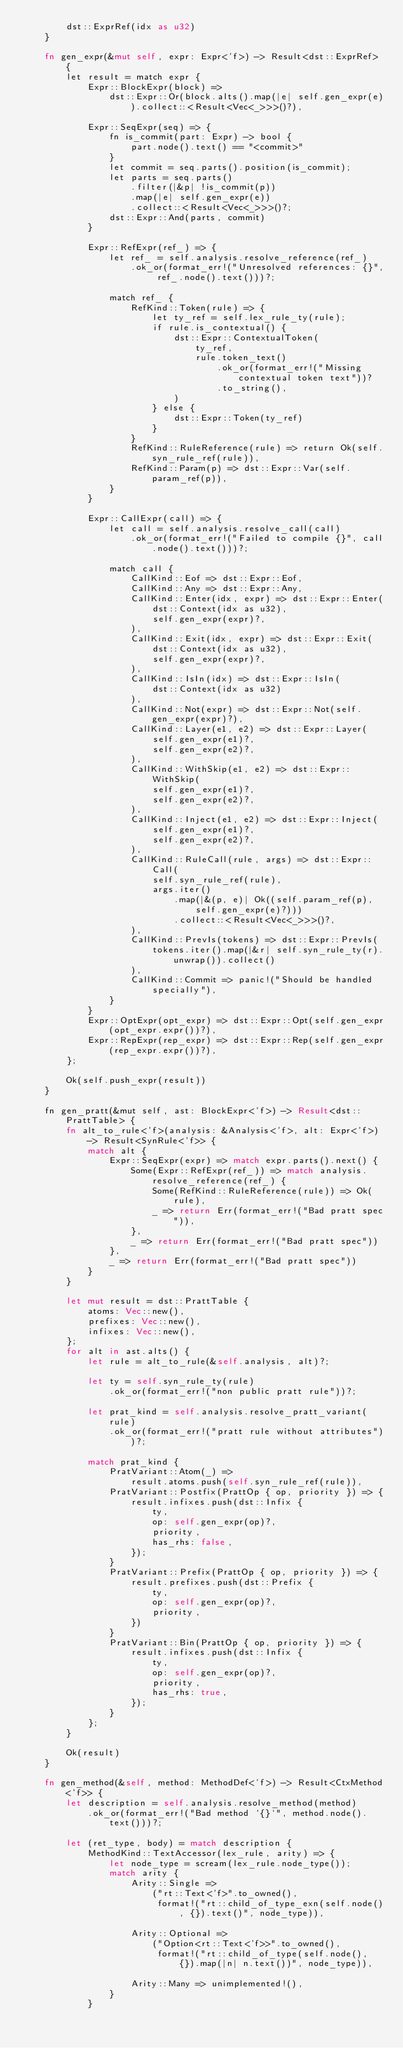<code> <loc_0><loc_0><loc_500><loc_500><_Rust_>        dst::ExprRef(idx as u32)
    }

    fn gen_expr(&mut self, expr: Expr<'f>) -> Result<dst::ExprRef> {
        let result = match expr {
            Expr::BlockExpr(block) =>
                dst::Expr::Or(block.alts().map(|e| self.gen_expr(e)).collect::<Result<Vec<_>>>()?),

            Expr::SeqExpr(seq) => {
                fn is_commit(part: Expr) -> bool {
                    part.node().text() == "<commit>"
                }
                let commit = seq.parts().position(is_commit);
                let parts = seq.parts()
                    .filter(|&p| !is_commit(p))
                    .map(|e| self.gen_expr(e))
                    .collect::<Result<Vec<_>>>()?;
                dst::Expr::And(parts, commit)
            }

            Expr::RefExpr(ref_) => {
                let ref_ = self.analysis.resolve_reference(ref_)
                    .ok_or(format_err!("Unresolved references: {}", ref_.node().text()))?;

                match ref_ {
                    RefKind::Token(rule) => {
                        let ty_ref = self.lex_rule_ty(rule);
                        if rule.is_contextual() {
                            dst::Expr::ContextualToken(
                                ty_ref,
                                rule.token_text()
                                    .ok_or(format_err!("Missing contextual token text"))?
                                    .to_string(),
                            )
                        } else {
                            dst::Expr::Token(ty_ref)
                        }
                    }
                    RefKind::RuleReference(rule) => return Ok(self.syn_rule_ref(rule)),
                    RefKind::Param(p) => dst::Expr::Var(self.param_ref(p)),
                }
            }

            Expr::CallExpr(call) => {
                let call = self.analysis.resolve_call(call)
                    .ok_or(format_err!("Failed to compile {}", call.node().text()))?;

                match call {
                    CallKind::Eof => dst::Expr::Eof,
                    CallKind::Any => dst::Expr::Any,
                    CallKind::Enter(idx, expr) => dst::Expr::Enter(
                        dst::Context(idx as u32),
                        self.gen_expr(expr)?,
                    ),
                    CallKind::Exit(idx, expr) => dst::Expr::Exit(
                        dst::Context(idx as u32),
                        self.gen_expr(expr)?,
                    ),
                    CallKind::IsIn(idx) => dst::Expr::IsIn(
                        dst::Context(idx as u32)
                    ),
                    CallKind::Not(expr) => dst::Expr::Not(self.gen_expr(expr)?),
                    CallKind::Layer(e1, e2) => dst::Expr::Layer(
                        self.gen_expr(e1)?,
                        self.gen_expr(e2)?,
                    ),
                    CallKind::WithSkip(e1, e2) => dst::Expr::WithSkip(
                        self.gen_expr(e1)?,
                        self.gen_expr(e2)?,
                    ),
                    CallKind::Inject(e1, e2) => dst::Expr::Inject(
                        self.gen_expr(e1)?,
                        self.gen_expr(e2)?,
                    ),
                    CallKind::RuleCall(rule, args) => dst::Expr::Call(
                        self.syn_rule_ref(rule),
                        args.iter()
                            .map(|&(p, e)| Ok((self.param_ref(p), self.gen_expr(e)?)))
                            .collect::<Result<Vec<_>>>()?,
                    ),
                    CallKind::PrevIs(tokens) => dst::Expr::PrevIs(
                        tokens.iter().map(|&r| self.syn_rule_ty(r).unwrap()).collect()
                    ),
                    CallKind::Commit => panic!("Should be handled specially"),
                }
            }
            Expr::OptExpr(opt_expr) => dst::Expr::Opt(self.gen_expr(opt_expr.expr())?),
            Expr::RepExpr(rep_expr) => dst::Expr::Rep(self.gen_expr(rep_expr.expr())?),
        };

        Ok(self.push_expr(result))
    }

    fn gen_pratt(&mut self, ast: BlockExpr<'f>) -> Result<dst::PrattTable> {
        fn alt_to_rule<'f>(analysis: &Analysis<'f>, alt: Expr<'f>) -> Result<SynRule<'f>> {
            match alt {
                Expr::SeqExpr(expr) => match expr.parts().next() {
                    Some(Expr::RefExpr(ref_)) => match analysis.resolve_reference(ref_) {
                        Some(RefKind::RuleReference(rule)) => Ok(rule),
                        _ => return Err(format_err!("Bad pratt spec")),
                    },
                    _ => return Err(format_err!("Bad pratt spec"))
                },
                _ => return Err(format_err!("Bad pratt spec"))
            }
        }

        let mut result = dst::PrattTable {
            atoms: Vec::new(),
            prefixes: Vec::new(),
            infixes: Vec::new(),
        };
        for alt in ast.alts() {
            let rule = alt_to_rule(&self.analysis, alt)?;

            let ty = self.syn_rule_ty(rule)
                .ok_or(format_err!("non public pratt rule"))?;

            let prat_kind = self.analysis.resolve_pratt_variant(rule)
                .ok_or(format_err!("pratt rule without attributes"))?;

            match prat_kind {
                PratVariant::Atom(_) =>
                    result.atoms.push(self.syn_rule_ref(rule)),
                PratVariant::Postfix(PrattOp { op, priority }) => {
                    result.infixes.push(dst::Infix {
                        ty,
                        op: self.gen_expr(op)?,
                        priority,
                        has_rhs: false,
                    });
                }
                PratVariant::Prefix(PrattOp { op, priority }) => {
                    result.prefixes.push(dst::Prefix {
                        ty,
                        op: self.gen_expr(op)?,
                        priority,
                    })
                }
                PratVariant::Bin(PrattOp { op, priority }) => {
                    result.infixes.push(dst::Infix {
                        ty,
                        op: self.gen_expr(op)?,
                        priority,
                        has_rhs: true,
                    });
                }
            };
        }

        Ok(result)
    }

    fn gen_method(&self, method: MethodDef<'f>) -> Result<CtxMethod<'f>> {
        let description = self.analysis.resolve_method(method)
            .ok_or(format_err!("Bad method `{}`", method.node().text()))?;

        let (ret_type, body) = match description {
            MethodKind::TextAccessor(lex_rule, arity) => {
                let node_type = scream(lex_rule.node_type());
                match arity {
                    Arity::Single =>
                        ("rt::Text<'f>".to_owned(),
                         format!("rt::child_of_type_exn(self.node(), {}).text()", node_type)),

                    Arity::Optional =>
                        ("Option<rt::Text<'f>>".to_owned(),
                         format!("rt::child_of_type(self.node(), {}).map(|n| n.text())", node_type)),

                    Arity::Many => unimplemented!(),
                }
            }</code> 